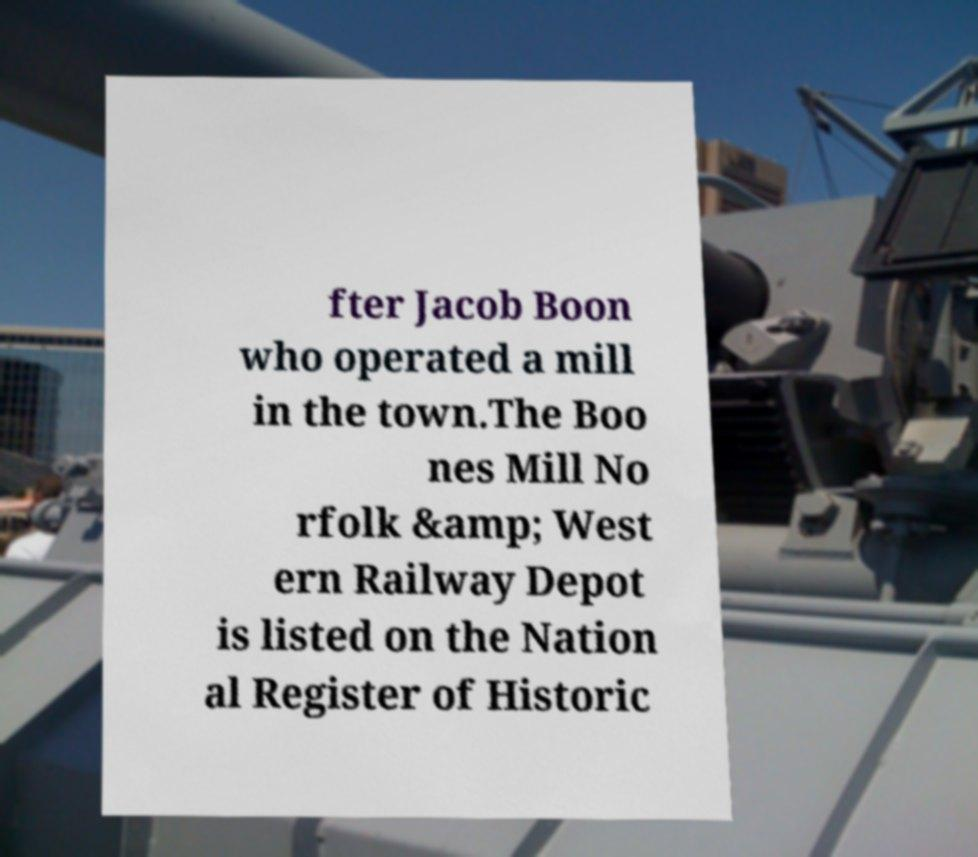What messages or text are displayed in this image? I need them in a readable, typed format. fter Jacob Boon who operated a mill in the town.The Boo nes Mill No rfolk &amp; West ern Railway Depot is listed on the Nation al Register of Historic 